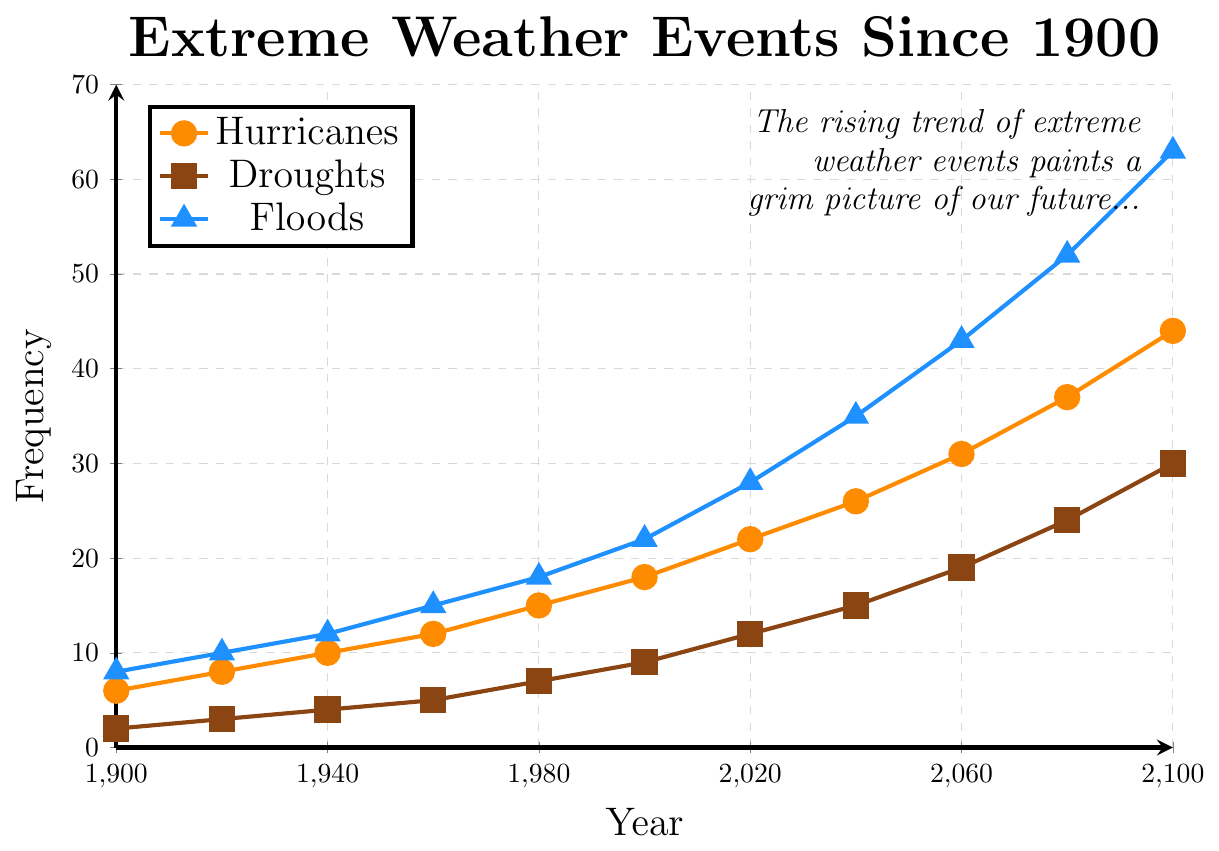What trend do you observe in the frequency of droughts between 2000 and 2040? Between 2000 and 2040, the frequency of droughts increases from 9 to 15. This upward trend shows a consistent increase in the number of droughts over the 40-year period.
Answer: Increasing How much has the frequency of floods increased from 1900 to 2100? In 1900, there were 8 floods, and in 2100, there were 63 floods. The increase in the number of floods is 63 - 8 = 55.
Answer: 55 Between which two decades did the frequency of hurricanes increase the most? The frequency of hurricanes increased the most between 2060 and 2080, where it went from 31 to 37, an increase of 6. This is the highest increase compared to other decades.
Answer: 2060-2080 Which type of extreme weather event shows the highest frequency in 2020? In 2020, the frequency of floods is 28, hurricanes is 22, and droughts is 12. Floods have the highest frequency.
Answer: Floods In what year do hurricanes reach a frequency of 31? According to the plot, hurricanes reach a frequency of 31 in the year 2060.
Answer: 2060 Compare the frequencies of hurricanes and droughts in the year 1980. Which is higher and by how much? In 1980, the frequency of hurricanes is 15 and droughts is 7. Hurricanes are higher by 15 - 7 = 8.
Answer: Hurricanes by 8 What is the average frequency of floods in the years 1900, 1940, and 1980? In 1900, floods are 8, in 1940 they are 12, and in 1980 they are 18. The average frequency is (8 + 12 + 18) / 3 = 38 / 3 = 12.67.
Answer: 12.67 By how many events does the frequency of droughts increase from 2060 to 2100? In 2060, droughts are 19, and in 2100, they are 30. The increase is 30 - 19 = 11.
Answer: 11 What color represents the frequency of floods in the plot? The frequency of floods is represented by the blue color in the plot.
Answer: Blue Considering all years, which extreme weather event shows the steepest upward trend? Observing the slopes of all three lines, floods show the steepest upward trend. The line representing floods increases sharply compared to hurricanes and droughts.
Answer: Floods 